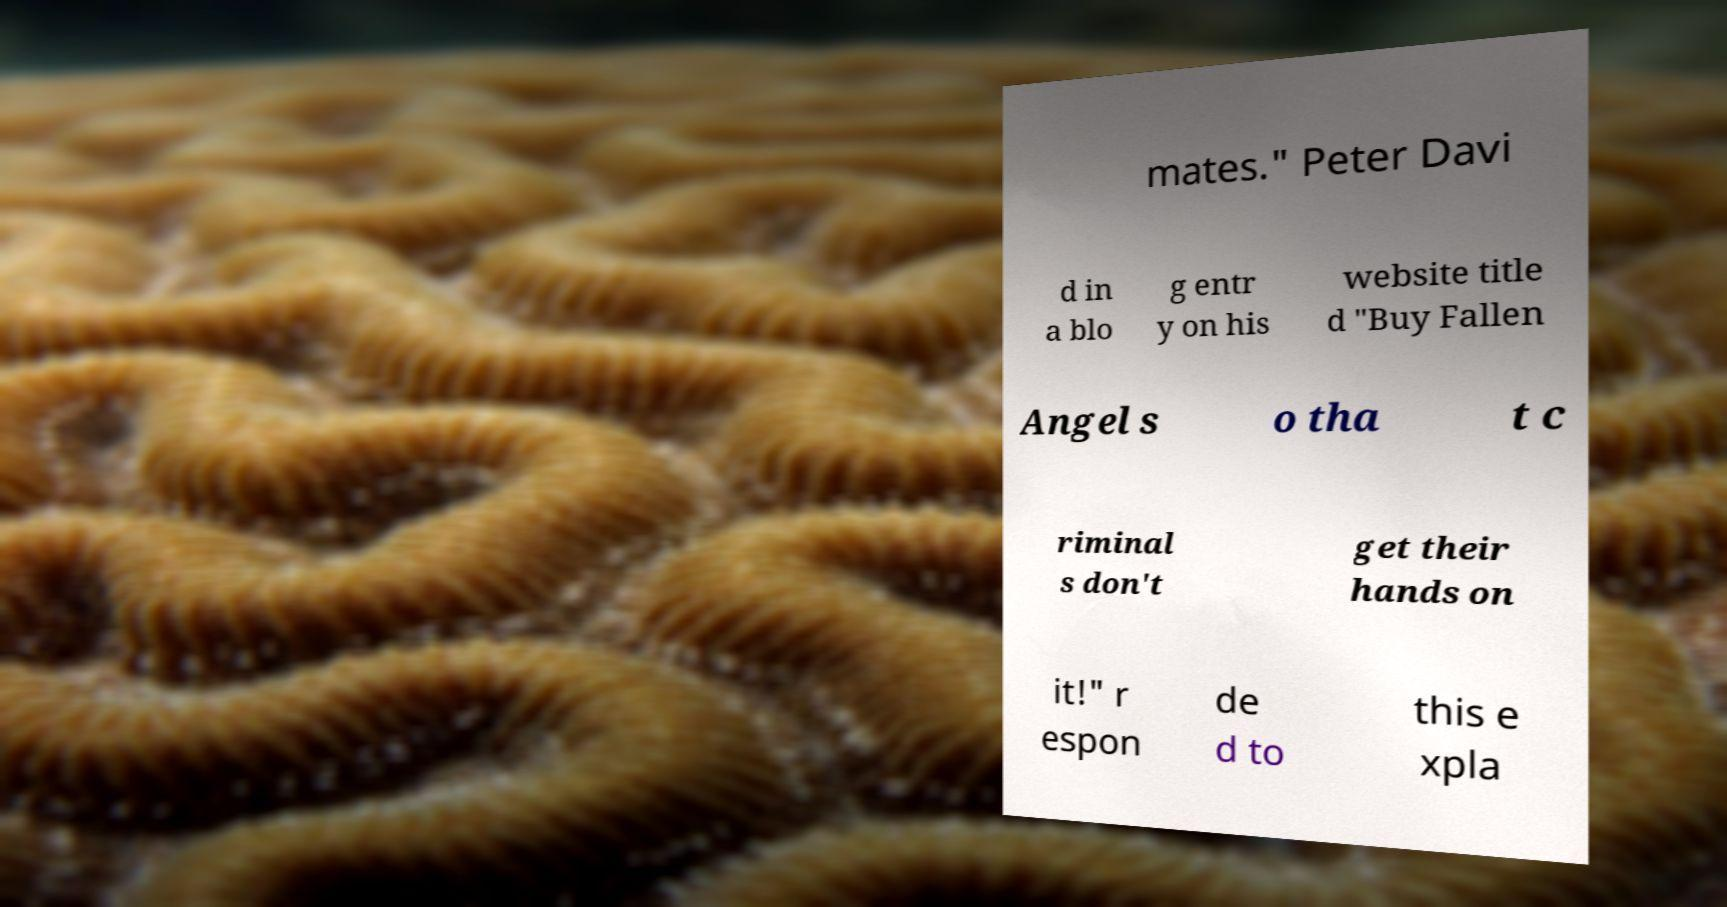Can you accurately transcribe the text from the provided image for me? mates." Peter Davi d in a blo g entr y on his website title d "Buy Fallen Angel s o tha t c riminal s don't get their hands on it!" r espon de d to this e xpla 